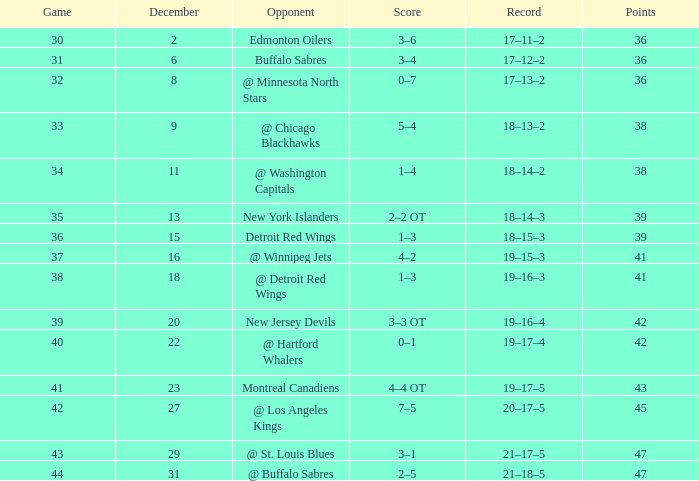Post december 29, what's the total score? 2–5. 